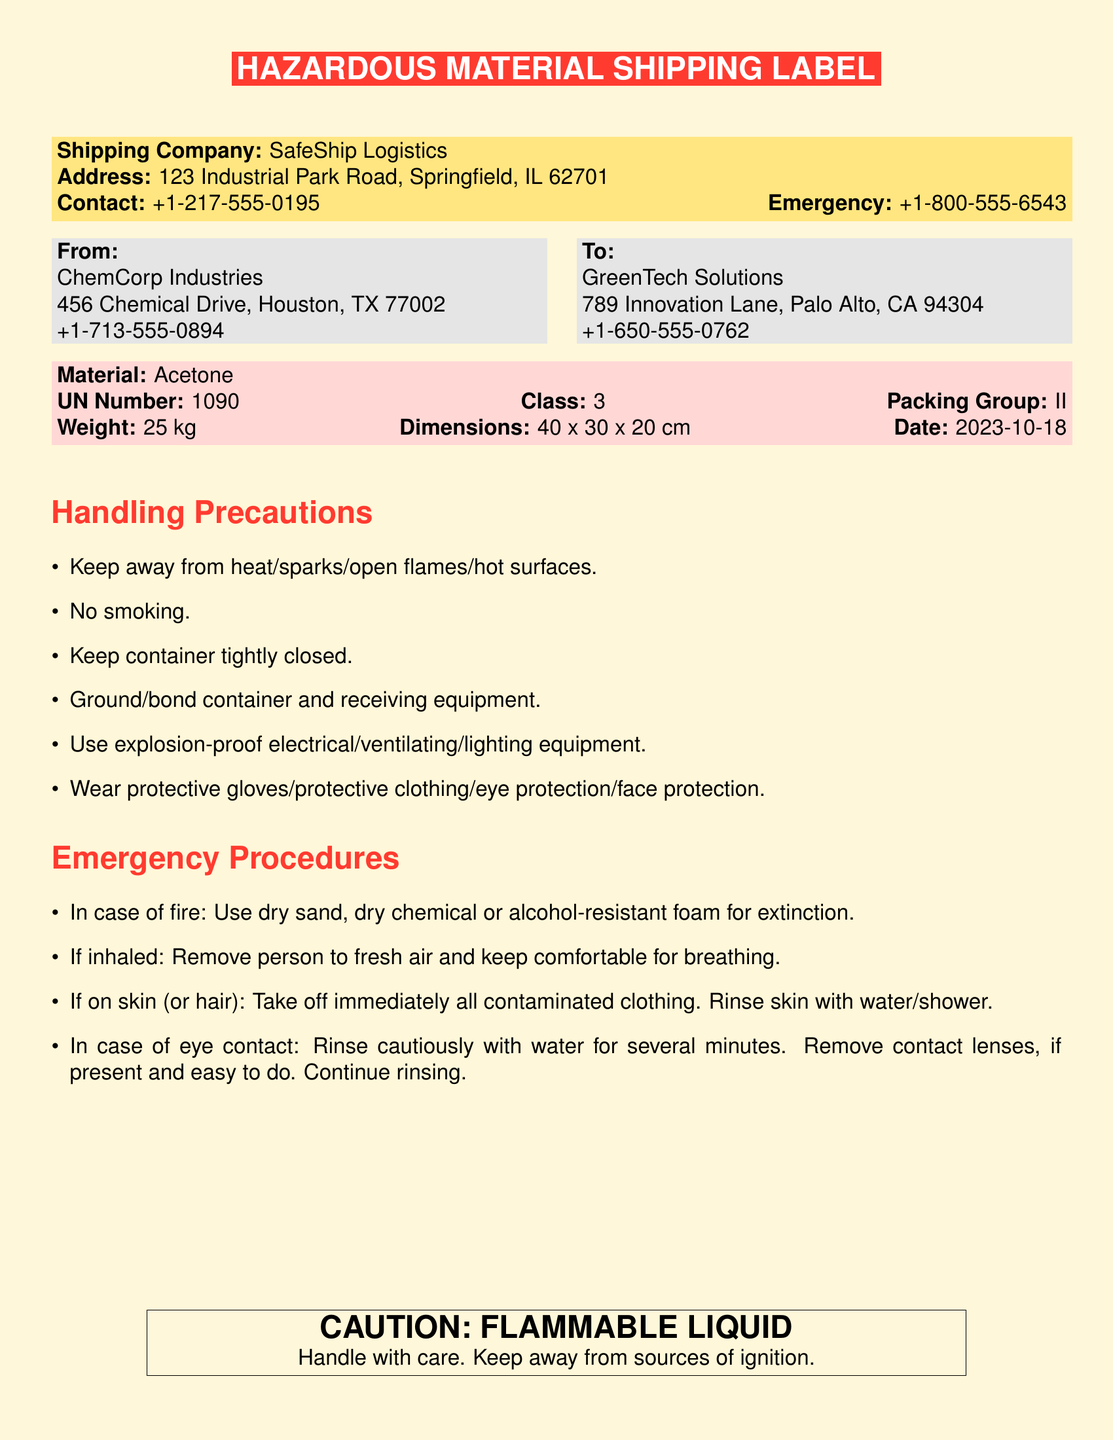What is the shipping company? The shipping company is listed at the top of the label.
Answer: SafeShip Logistics What is the UN number for the hazardous material? The UN number can be found in the material section of the document.
Answer: 1090 What is the emergency contact number? The emergency contact number is provided alongside the shipping company contact information.
Answer: +1-800-555-6543 What is the weight of the material? The weight is specified in the material section of the document.
Answer: 25 kg What class does the material fall under? The class of the hazardous material is indicated in the same section as the UN number.
Answer: 3 What are the handling precautions related to smoking? The relevant precaution is mentioned in a list of handling precautions.
Answer: No smoking What should be done in case of fire? This information is detailed in the emergency procedures section of the document.
Answer: Use dry sand, dry chemical or alcohol-resistant foam for extinction What is the packing group of the material? The packing group is included in the material information section.
Answer: II What precaution should be taken when contacting the material? The precaution concerning contact with the material is included in the handling precautions.
Answer: Wear protective gloves/protective clothing/eye protection/face protection 